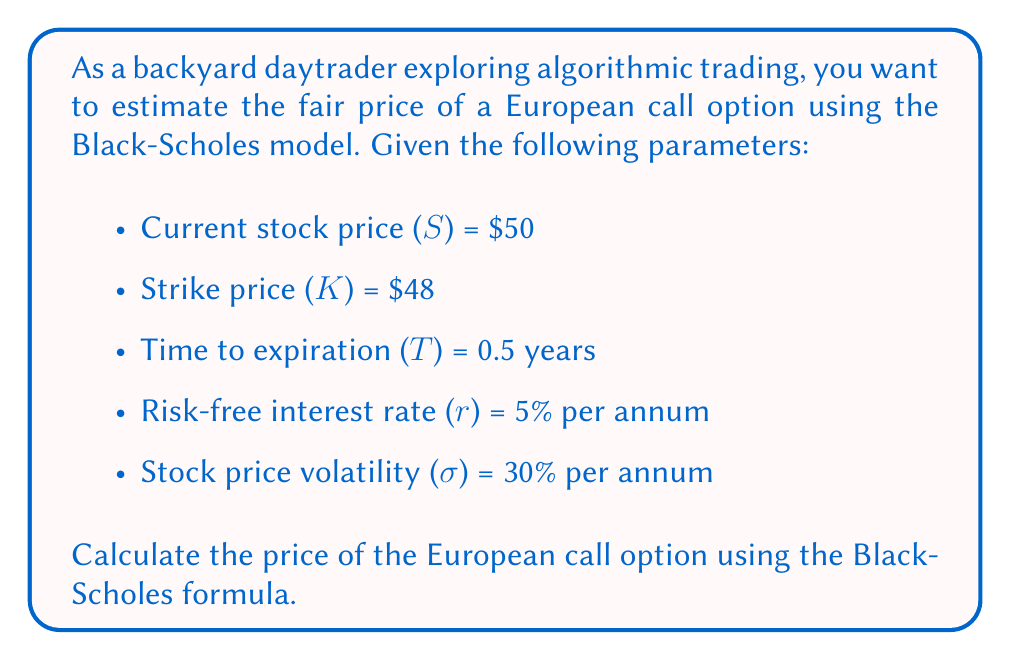Help me with this question. To solve this problem using the Black-Scholes model, we'll follow these steps:

1. Calculate d1 and d2:
   $$d_1 = \frac{\ln(S/K) + (r + \sigma^2/2)T}{\sigma\sqrt{T}}$$
   $$d_2 = d_1 - \sigma\sqrt{T}$$

2. Find N(d1) and N(d2) using the standard normal cumulative distribution function.

3. Apply the Black-Scholes formula:
   $$C = SN(d_1) - Ke^{-rT}N(d_2)$$

Step 1: Calculate d1 and d2
$$d_1 = \frac{\ln(50/48) + (0.05 + 0.3^2/2) * 0.5}{0.3\sqrt{0.5}} = 0.7136$$
$$d_2 = 0.7136 - 0.3\sqrt{0.5} = 0.5014$$

Step 2: Find N(d1) and N(d2)
Using a standard normal distribution table or calculator:
N(d1) = N(0.7136) ≈ 0.7622
N(d2) = N(0.5014) ≈ 0.6919

Step 3: Apply the Black-Scholes formula
$$C = 50 * 0.7622 - 48 * e^{-0.05 * 0.5} * 0.6919$$
$$C = 38.11 - 48 * 0.9753 * 0.6919$$
$$C = 38.11 - 32.35$$
$$C = 5.76$$

Therefore, the estimated fair price of the European call option is $5.76.
Answer: $5.76 